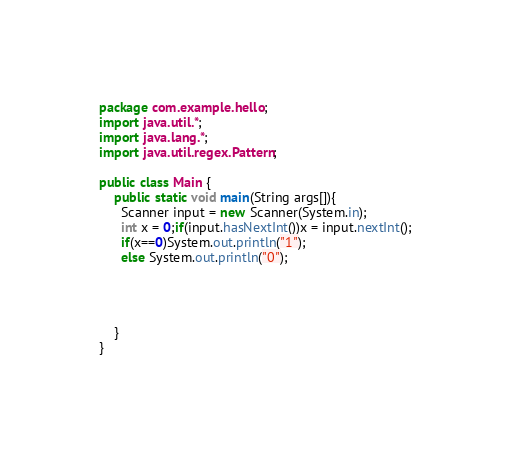Convert code to text. <code><loc_0><loc_0><loc_500><loc_500><_Java_>package com.example.hello;
import java.util.*;
import java.lang.*;
import java.util.regex.Pattern;

public class Main {
    public static void main(String args[]){
      Scanner input = new Scanner(System.in);
      int x = 0;if(input.hasNextInt())x = input.nextInt();
      if(x==0)System.out.println("1");
      else System.out.println("0");




    }
}
</code> 